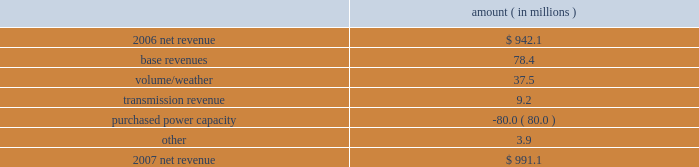Entergy louisiana , llc management's financial discussion and analysis 2007 compared to 2006 net revenue consists of operating revenues net of : 1 ) fuel , fuel-related expenses , and gas purchased for resale , 2 ) purchased power expenses , and 3 ) other regulatory charges ( credits ) .
Following is an analysis of the change in net revenue comparing 2007 to 2006 .
Amount ( in millions ) .
The base revenues variance is primarily due to increases effective september 2006 for the 2005 formula rate plan filing to recover lpsc-approved incremental deferred and ongoing capacity costs .
See "state and local rate regulation" below and note 2 to the financial statements for a discussion of the formula rate plan filing .
The volume/weather variance is due to increased electricity usage , including electricity sales during the unbilled service period .
Billed retail electricity usage increased a total of 666 gwh in all sectors compared to 2006 .
See "critical accounting estimates" below and note 1 to the financial statements for further discussion of the accounting for unbilled revenues .
The transmission revenue variance is primarily due to higher rates .
The purchased power capacity variance is primarily due to higher purchased power capacity charges and the amortization of capacity charges effective september 2006 as a result of the formula rate plan filing in may 2006 .
A portion of the purchased power capacity costs is offset in base revenues due to a base rate increase implemented to recover incremental deferred and ongoing purchased power capacity charges , as mentioned above .
See "state and local rate regulation" below and note 2 to the financial statements for a discussion of the formula rate plan filing .
Gross operating revenues , fuel , purchased power expenses , and other regulatory charges ( credits ) gross operating revenues increased primarily due to : an increase of $ 143.1 million in fuel cost recovery revenues due to higher fuel rates and usage ; an increase of $ 78.4 million in base revenues , as discussed above ; and an increase of $ 37.5 million related to volume/weather , as discussed above .
Fuel and purchased power expenses increased primarily due to an increase in net area demand and an increase in deferred fuel expense as a result of higher fuel rates , as discussed above .
Other regulatory credits decreased primarily due to the deferral of capacity charges in 2006 in addition to the amortization of these capacity charges in 2007 as a result of the may 2006 formula rate plan filing ( for the 2005 test year ) with the lpsc to recover such costs through base rates effective september 2006 .
See note 2 to the financial statements for a discussion of the formula rate plan and storm cost recovery filings with the lpsc. .
What percent of the net change in revenue between 2007 and 2008 was due to volume/weather? 
Computations: (37.5 / (991.1 - 942.1))
Answer: 0.76531. 